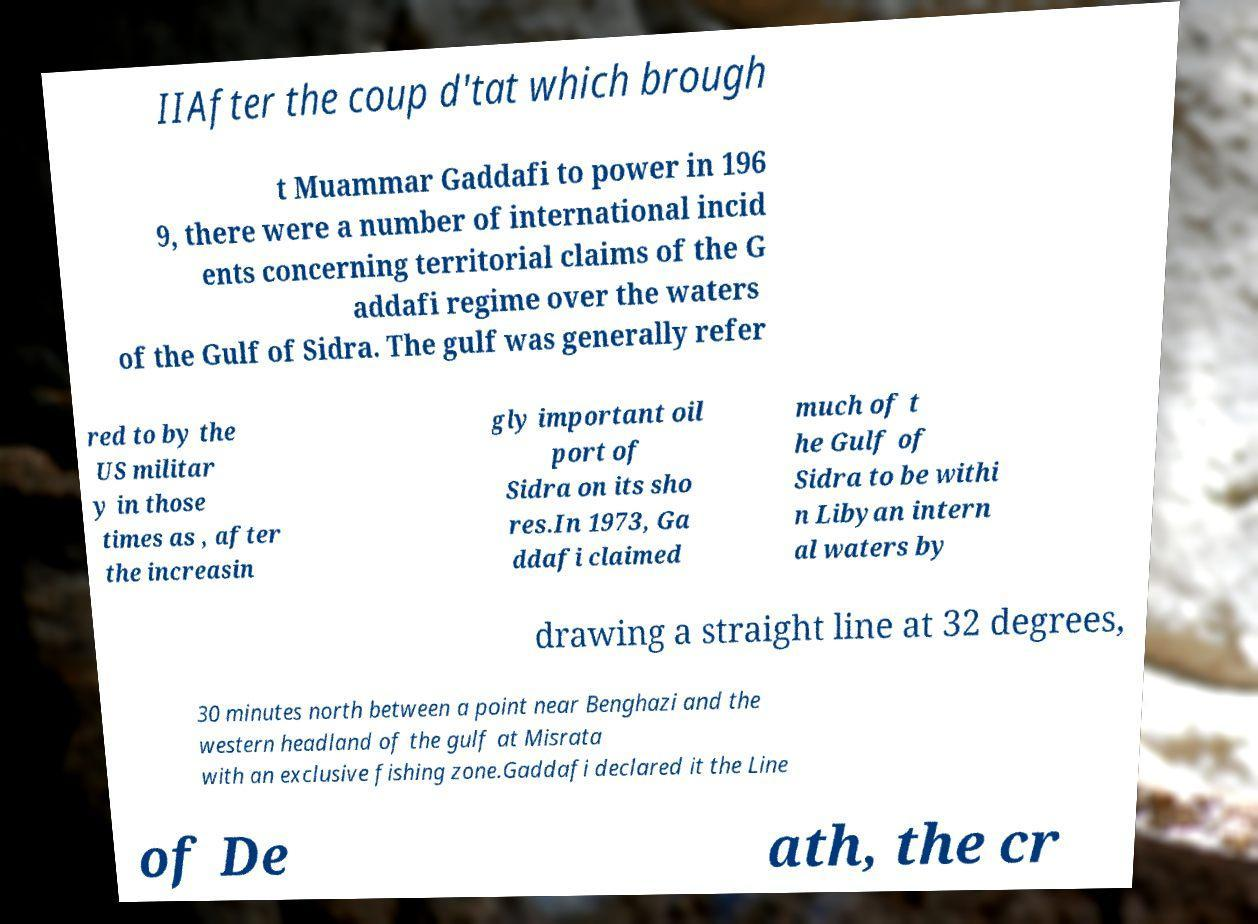There's text embedded in this image that I need extracted. Can you transcribe it verbatim? IIAfter the coup d'tat which brough t Muammar Gaddafi to power in 196 9, there were a number of international incid ents concerning territorial claims of the G addafi regime over the waters of the Gulf of Sidra. The gulf was generally refer red to by the US militar y in those times as , after the increasin gly important oil port of Sidra on its sho res.In 1973, Ga ddafi claimed much of t he Gulf of Sidra to be withi n Libyan intern al waters by drawing a straight line at 32 degrees, 30 minutes north between a point near Benghazi and the western headland of the gulf at Misrata with an exclusive fishing zone.Gaddafi declared it the Line of De ath, the cr 